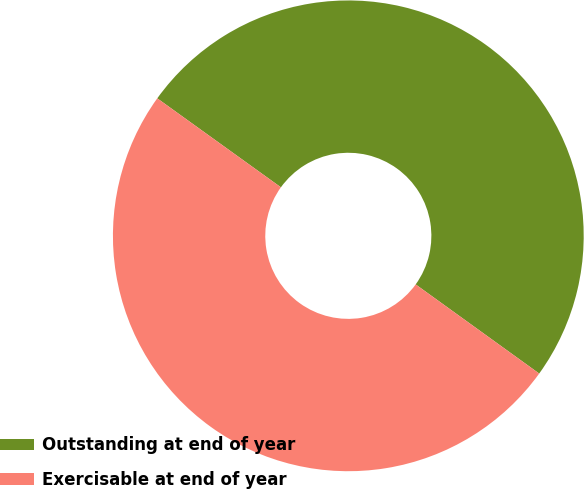<chart> <loc_0><loc_0><loc_500><loc_500><pie_chart><fcel>Outstanding at end of year<fcel>Exercisable at end of year<nl><fcel>50.02%<fcel>49.98%<nl></chart> 